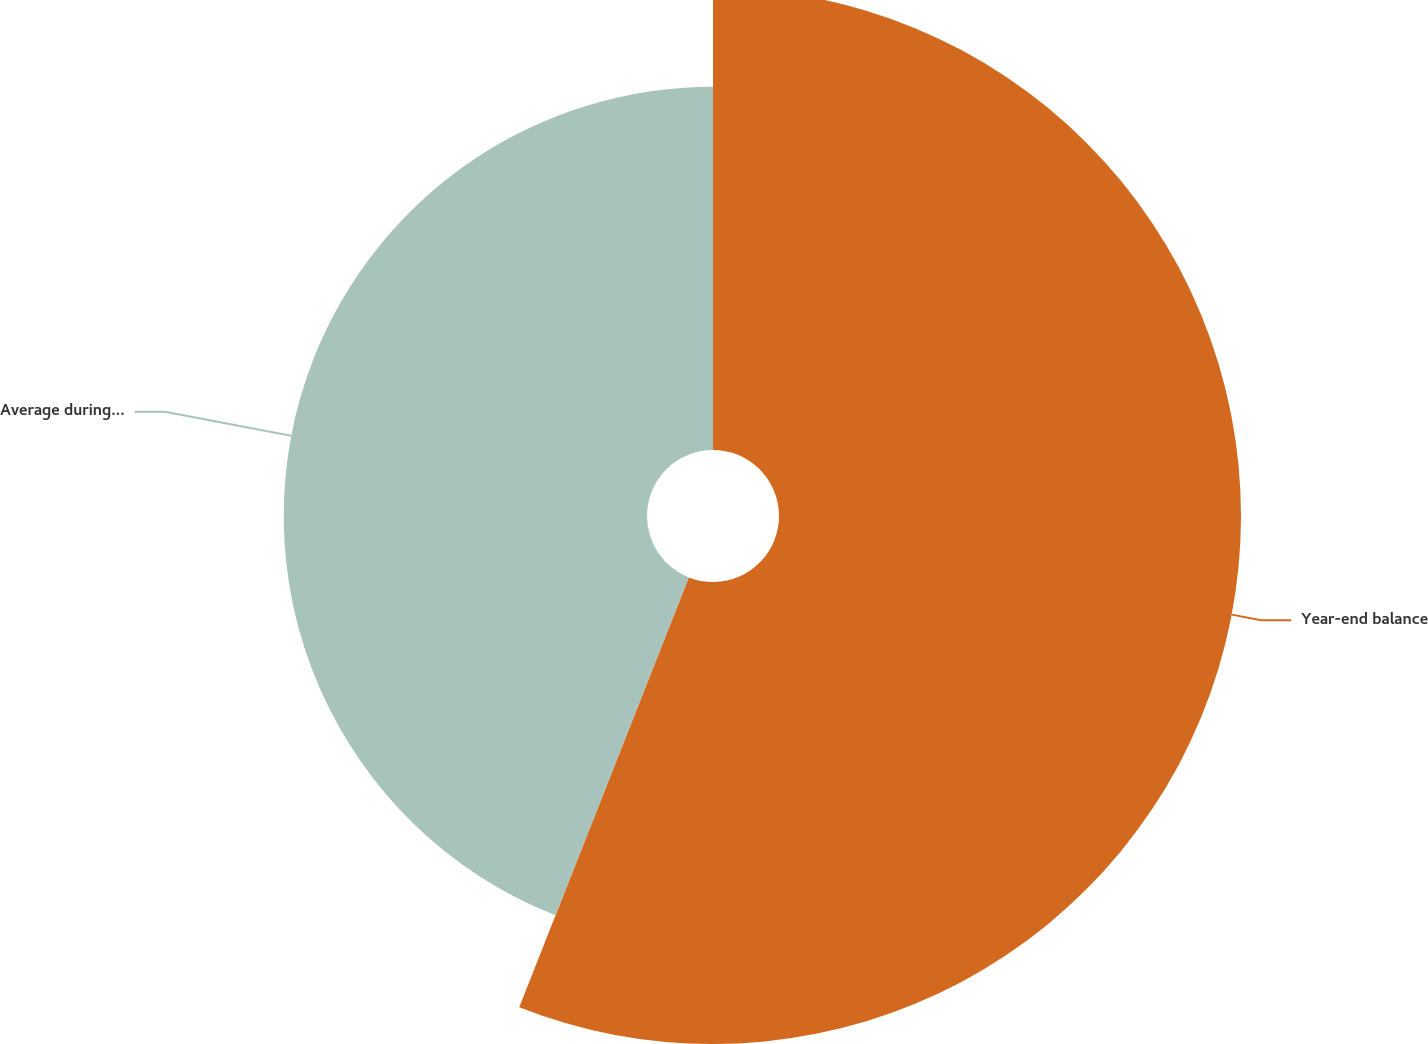Convert chart to OTSL. <chart><loc_0><loc_0><loc_500><loc_500><pie_chart><fcel>Year-end balance<fcel>Average during year<nl><fcel>55.98%<fcel>44.02%<nl></chart> 